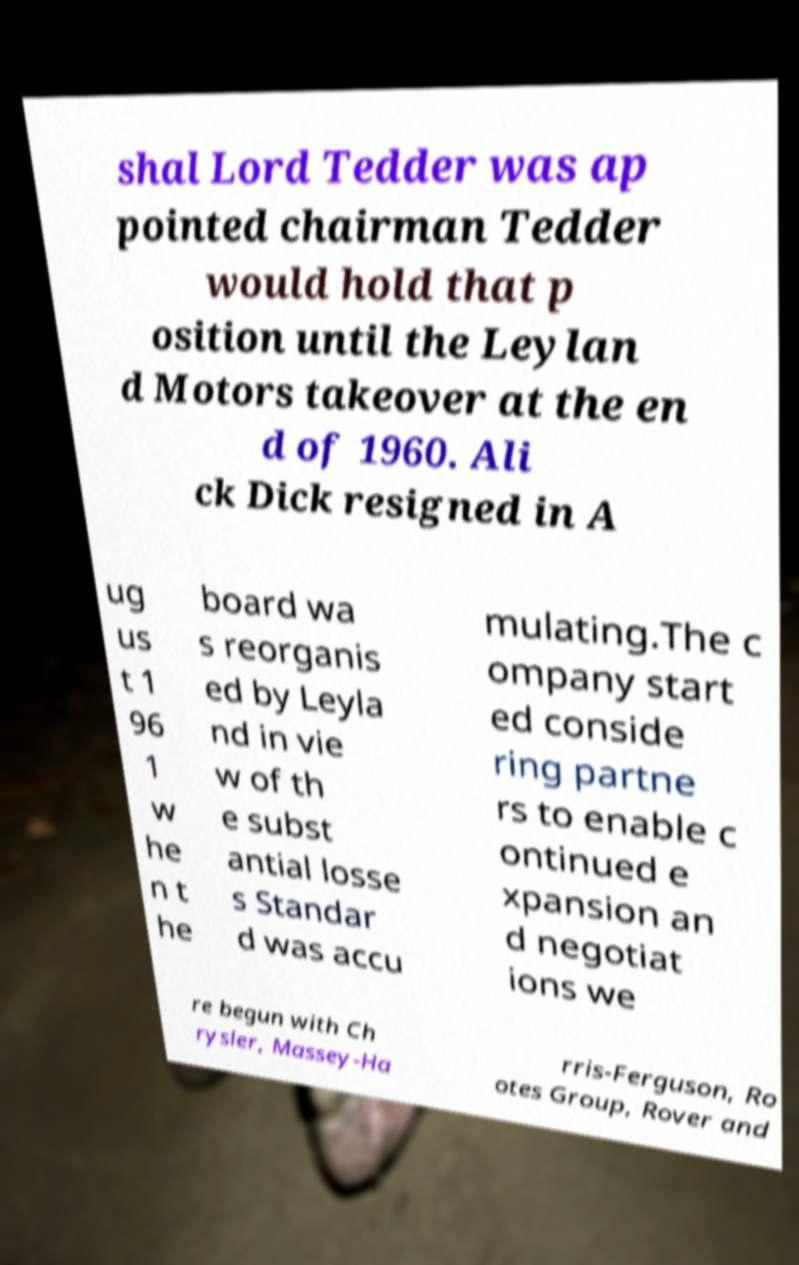Please identify and transcribe the text found in this image. shal Lord Tedder was ap pointed chairman Tedder would hold that p osition until the Leylan d Motors takeover at the en d of 1960. Ali ck Dick resigned in A ug us t 1 96 1 w he n t he board wa s reorganis ed by Leyla nd in vie w of th e subst antial losse s Standar d was accu mulating.The c ompany start ed conside ring partne rs to enable c ontinued e xpansion an d negotiat ions we re begun with Ch rysler, Massey-Ha rris-Ferguson, Ro otes Group, Rover and 